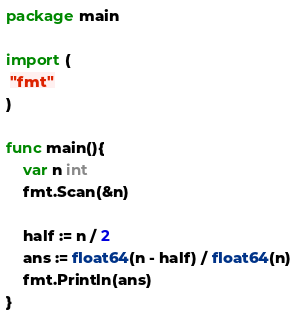Convert code to text. <code><loc_0><loc_0><loc_500><loc_500><_Go_>package main

import (
 "fmt"
)

func main(){
    var n int
    fmt.Scan(&n)

    half := n / 2
    ans := float64(n - half) / float64(n)
    fmt.Println(ans)
}</code> 